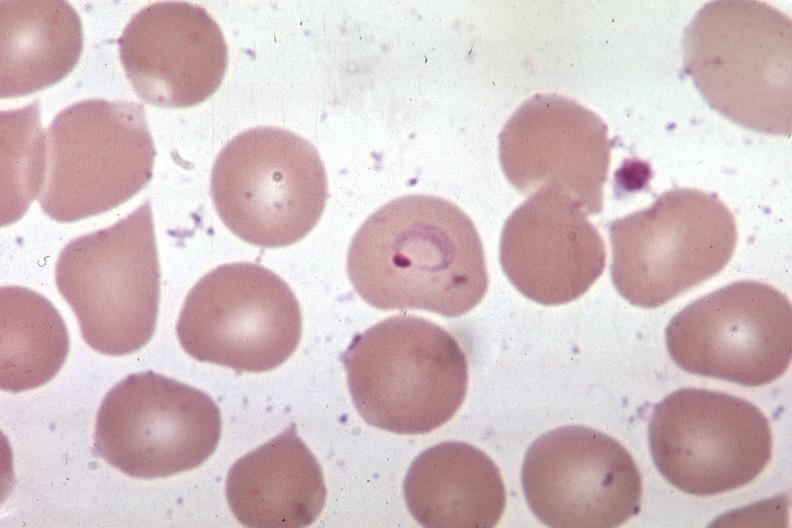what is present?
Answer the question using a single word or phrase. Blood 